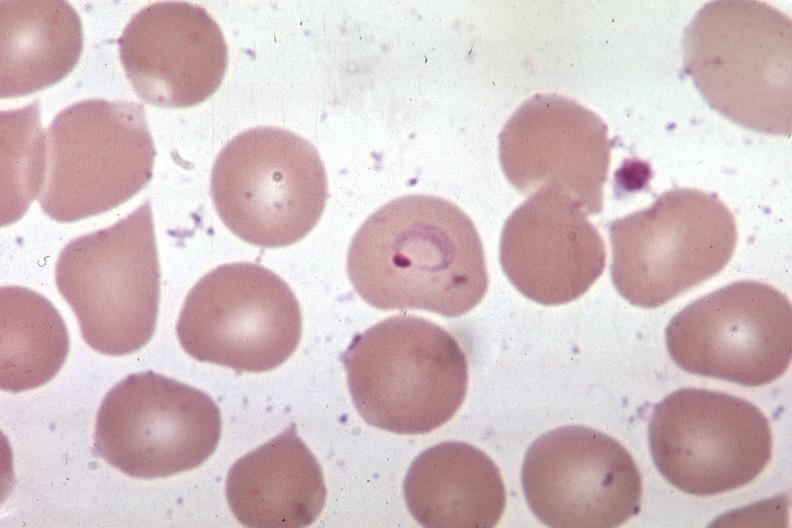what is present?
Answer the question using a single word or phrase. Blood 